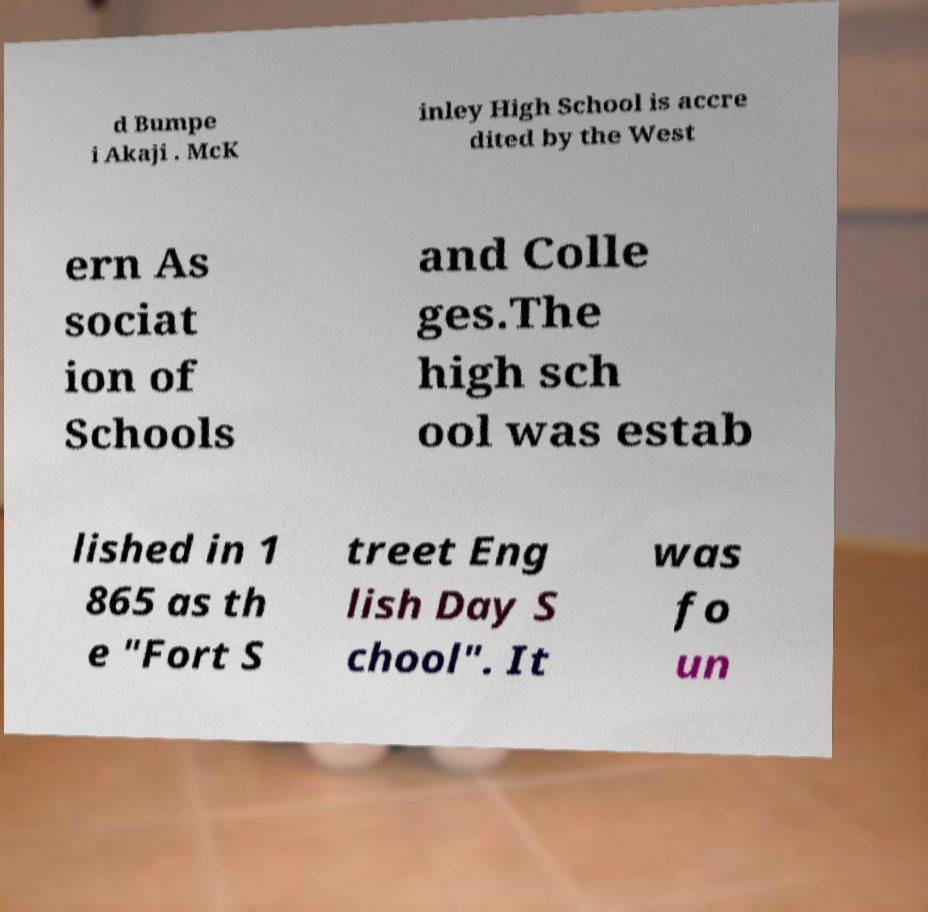What messages or text are displayed in this image? I need them in a readable, typed format. d Bumpe i Akaji . McK inley High School is accre dited by the West ern As sociat ion of Schools and Colle ges.The high sch ool was estab lished in 1 865 as th e "Fort S treet Eng lish Day S chool". It was fo un 